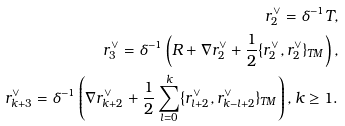Convert formula to latex. <formula><loc_0><loc_0><loc_500><loc_500>r ^ { \vee } _ { 2 } = \delta ^ { - 1 } T , \\ r ^ { \vee } _ { 3 } = \delta ^ { - 1 } \left ( R + \nabla r ^ { \vee } _ { 2 } + \frac { 1 } { 2 } \{ r ^ { \vee } _ { 2 } , r ^ { \vee } _ { 2 } \} _ { T M } \right ) , \\ r ^ { \vee } _ { k + 3 } = \delta ^ { - 1 } \left ( \nabla r ^ { \vee } _ { k + 2 } + \frac { 1 } { 2 } \sum _ { l = 0 } ^ { k } \{ r ^ { \vee } _ { l + 2 } , r ^ { \vee } _ { k - l + 2 } \} _ { T M } \right ) , k \geq 1 .</formula> 